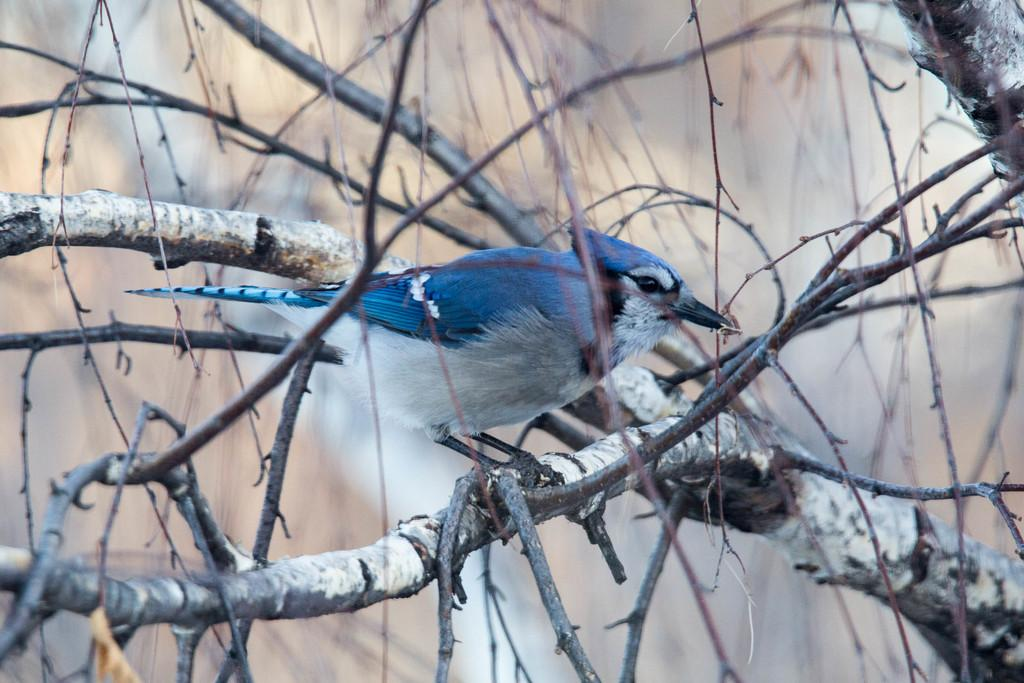What type of animal can be seen in the image? There is a bird in the image. Where is the bird located? The bird is on a tree. Can you describe the background of the image? The background of the image is blurred. What type of yarn is the bird using to weave a nest in the image? There is no yarn present in the image, nor is the bird weaving a nest. 